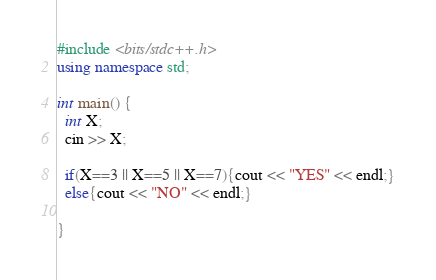Convert code to text. <code><loc_0><loc_0><loc_500><loc_500><_C++_>#include <bits/stdc++.h>
using namespace std;

int main() {
  int X;
  cin >> X;
  
  if(X==3 || X==5 || X==7){cout << "YES" << endl;}
  else{cout << "NO" << endl;}
                        
}</code> 